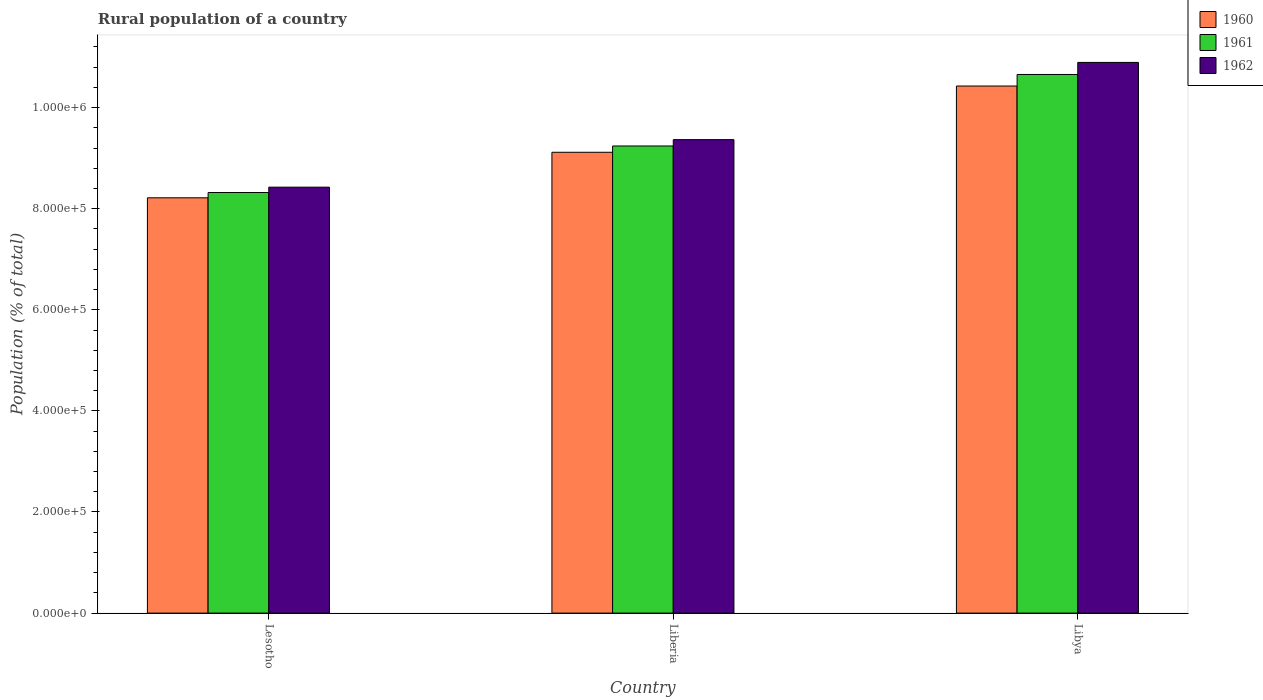How many groups of bars are there?
Provide a short and direct response. 3. Are the number of bars on each tick of the X-axis equal?
Ensure brevity in your answer.  Yes. How many bars are there on the 1st tick from the left?
Offer a very short reply. 3. What is the label of the 2nd group of bars from the left?
Your answer should be very brief. Liberia. In how many cases, is the number of bars for a given country not equal to the number of legend labels?
Your response must be concise. 0. What is the rural population in 1962 in Lesotho?
Make the answer very short. 8.43e+05. Across all countries, what is the maximum rural population in 1962?
Your answer should be compact. 1.09e+06. Across all countries, what is the minimum rural population in 1960?
Make the answer very short. 8.22e+05. In which country was the rural population in 1962 maximum?
Your response must be concise. Libya. In which country was the rural population in 1960 minimum?
Offer a very short reply. Lesotho. What is the total rural population in 1962 in the graph?
Keep it short and to the point. 2.87e+06. What is the difference between the rural population in 1961 in Lesotho and that in Liberia?
Your response must be concise. -9.21e+04. What is the difference between the rural population in 1962 in Lesotho and the rural population in 1961 in Libya?
Provide a succinct answer. -2.23e+05. What is the average rural population in 1960 per country?
Your answer should be compact. 9.25e+05. What is the difference between the rural population of/in 1960 and rural population of/in 1961 in Libya?
Make the answer very short. -2.28e+04. What is the ratio of the rural population in 1962 in Liberia to that in Libya?
Your response must be concise. 0.86. What is the difference between the highest and the second highest rural population in 1960?
Make the answer very short. 9.01e+04. What is the difference between the highest and the lowest rural population in 1960?
Provide a short and direct response. 2.21e+05. Is the sum of the rural population in 1962 in Lesotho and Libya greater than the maximum rural population in 1961 across all countries?
Make the answer very short. Yes. Is it the case that in every country, the sum of the rural population in 1961 and rural population in 1960 is greater than the rural population in 1962?
Your answer should be compact. Yes. How many bars are there?
Give a very brief answer. 9. How many countries are there in the graph?
Keep it short and to the point. 3. What is the difference between two consecutive major ticks on the Y-axis?
Give a very brief answer. 2.00e+05. Are the values on the major ticks of Y-axis written in scientific E-notation?
Provide a succinct answer. Yes. Does the graph contain grids?
Give a very brief answer. No. How many legend labels are there?
Ensure brevity in your answer.  3. What is the title of the graph?
Give a very brief answer. Rural population of a country. Does "1998" appear as one of the legend labels in the graph?
Offer a very short reply. No. What is the label or title of the Y-axis?
Your response must be concise. Population (% of total). What is the Population (% of total) of 1960 in Lesotho?
Offer a very short reply. 8.22e+05. What is the Population (% of total) in 1961 in Lesotho?
Offer a very short reply. 8.32e+05. What is the Population (% of total) in 1962 in Lesotho?
Offer a terse response. 8.43e+05. What is the Population (% of total) of 1960 in Liberia?
Provide a succinct answer. 9.12e+05. What is the Population (% of total) in 1961 in Liberia?
Your answer should be very brief. 9.24e+05. What is the Population (% of total) in 1962 in Liberia?
Your answer should be very brief. 9.37e+05. What is the Population (% of total) in 1960 in Libya?
Provide a short and direct response. 1.04e+06. What is the Population (% of total) in 1961 in Libya?
Offer a terse response. 1.07e+06. What is the Population (% of total) in 1962 in Libya?
Your answer should be compact. 1.09e+06. Across all countries, what is the maximum Population (% of total) in 1960?
Your answer should be compact. 1.04e+06. Across all countries, what is the maximum Population (% of total) in 1961?
Provide a short and direct response. 1.07e+06. Across all countries, what is the maximum Population (% of total) in 1962?
Offer a very short reply. 1.09e+06. Across all countries, what is the minimum Population (% of total) of 1960?
Provide a short and direct response. 8.22e+05. Across all countries, what is the minimum Population (% of total) of 1961?
Offer a terse response. 8.32e+05. Across all countries, what is the minimum Population (% of total) of 1962?
Your answer should be compact. 8.43e+05. What is the total Population (% of total) of 1960 in the graph?
Keep it short and to the point. 2.78e+06. What is the total Population (% of total) in 1961 in the graph?
Offer a very short reply. 2.82e+06. What is the total Population (% of total) of 1962 in the graph?
Make the answer very short. 2.87e+06. What is the difference between the Population (% of total) of 1960 in Lesotho and that in Liberia?
Offer a very short reply. -9.01e+04. What is the difference between the Population (% of total) in 1961 in Lesotho and that in Liberia?
Ensure brevity in your answer.  -9.21e+04. What is the difference between the Population (% of total) in 1962 in Lesotho and that in Liberia?
Keep it short and to the point. -9.40e+04. What is the difference between the Population (% of total) in 1960 in Lesotho and that in Libya?
Give a very brief answer. -2.21e+05. What is the difference between the Population (% of total) of 1961 in Lesotho and that in Libya?
Offer a very short reply. -2.34e+05. What is the difference between the Population (% of total) in 1962 in Lesotho and that in Libya?
Offer a terse response. -2.47e+05. What is the difference between the Population (% of total) of 1960 in Liberia and that in Libya?
Ensure brevity in your answer.  -1.31e+05. What is the difference between the Population (% of total) of 1961 in Liberia and that in Libya?
Your response must be concise. -1.41e+05. What is the difference between the Population (% of total) in 1962 in Liberia and that in Libya?
Give a very brief answer. -1.53e+05. What is the difference between the Population (% of total) in 1960 in Lesotho and the Population (% of total) in 1961 in Liberia?
Your response must be concise. -1.03e+05. What is the difference between the Population (% of total) of 1960 in Lesotho and the Population (% of total) of 1962 in Liberia?
Your answer should be compact. -1.15e+05. What is the difference between the Population (% of total) of 1961 in Lesotho and the Population (% of total) of 1962 in Liberia?
Keep it short and to the point. -1.05e+05. What is the difference between the Population (% of total) of 1960 in Lesotho and the Population (% of total) of 1961 in Libya?
Your answer should be compact. -2.44e+05. What is the difference between the Population (% of total) in 1960 in Lesotho and the Population (% of total) in 1962 in Libya?
Keep it short and to the point. -2.68e+05. What is the difference between the Population (% of total) of 1961 in Lesotho and the Population (% of total) of 1962 in Libya?
Give a very brief answer. -2.57e+05. What is the difference between the Population (% of total) of 1960 in Liberia and the Population (% of total) of 1961 in Libya?
Offer a very short reply. -1.54e+05. What is the difference between the Population (% of total) of 1960 in Liberia and the Population (% of total) of 1962 in Libya?
Give a very brief answer. -1.78e+05. What is the difference between the Population (% of total) in 1961 in Liberia and the Population (% of total) in 1962 in Libya?
Provide a short and direct response. -1.65e+05. What is the average Population (% of total) of 1960 per country?
Your response must be concise. 9.25e+05. What is the average Population (% of total) of 1961 per country?
Give a very brief answer. 9.40e+05. What is the average Population (% of total) in 1962 per country?
Ensure brevity in your answer.  9.56e+05. What is the difference between the Population (% of total) in 1960 and Population (% of total) in 1961 in Lesotho?
Your answer should be compact. -1.04e+04. What is the difference between the Population (% of total) of 1960 and Population (% of total) of 1962 in Lesotho?
Make the answer very short. -2.10e+04. What is the difference between the Population (% of total) in 1961 and Population (% of total) in 1962 in Lesotho?
Keep it short and to the point. -1.06e+04. What is the difference between the Population (% of total) of 1960 and Population (% of total) of 1961 in Liberia?
Provide a short and direct response. -1.25e+04. What is the difference between the Population (% of total) in 1960 and Population (% of total) in 1962 in Liberia?
Give a very brief answer. -2.50e+04. What is the difference between the Population (% of total) in 1961 and Population (% of total) in 1962 in Liberia?
Give a very brief answer. -1.25e+04. What is the difference between the Population (% of total) in 1960 and Population (% of total) in 1961 in Libya?
Your answer should be very brief. -2.28e+04. What is the difference between the Population (% of total) in 1960 and Population (% of total) in 1962 in Libya?
Give a very brief answer. -4.67e+04. What is the difference between the Population (% of total) in 1961 and Population (% of total) in 1962 in Libya?
Offer a terse response. -2.39e+04. What is the ratio of the Population (% of total) of 1960 in Lesotho to that in Liberia?
Provide a succinct answer. 0.9. What is the ratio of the Population (% of total) of 1961 in Lesotho to that in Liberia?
Your answer should be compact. 0.9. What is the ratio of the Population (% of total) of 1962 in Lesotho to that in Liberia?
Provide a succinct answer. 0.9. What is the ratio of the Population (% of total) in 1960 in Lesotho to that in Libya?
Keep it short and to the point. 0.79. What is the ratio of the Population (% of total) in 1961 in Lesotho to that in Libya?
Provide a succinct answer. 0.78. What is the ratio of the Population (% of total) of 1962 in Lesotho to that in Libya?
Your response must be concise. 0.77. What is the ratio of the Population (% of total) of 1960 in Liberia to that in Libya?
Offer a very short reply. 0.87. What is the ratio of the Population (% of total) in 1961 in Liberia to that in Libya?
Provide a short and direct response. 0.87. What is the ratio of the Population (% of total) in 1962 in Liberia to that in Libya?
Ensure brevity in your answer.  0.86. What is the difference between the highest and the second highest Population (% of total) of 1960?
Make the answer very short. 1.31e+05. What is the difference between the highest and the second highest Population (% of total) in 1961?
Ensure brevity in your answer.  1.41e+05. What is the difference between the highest and the second highest Population (% of total) in 1962?
Ensure brevity in your answer.  1.53e+05. What is the difference between the highest and the lowest Population (% of total) of 1960?
Your response must be concise. 2.21e+05. What is the difference between the highest and the lowest Population (% of total) of 1961?
Provide a succinct answer. 2.34e+05. What is the difference between the highest and the lowest Population (% of total) in 1962?
Offer a very short reply. 2.47e+05. 